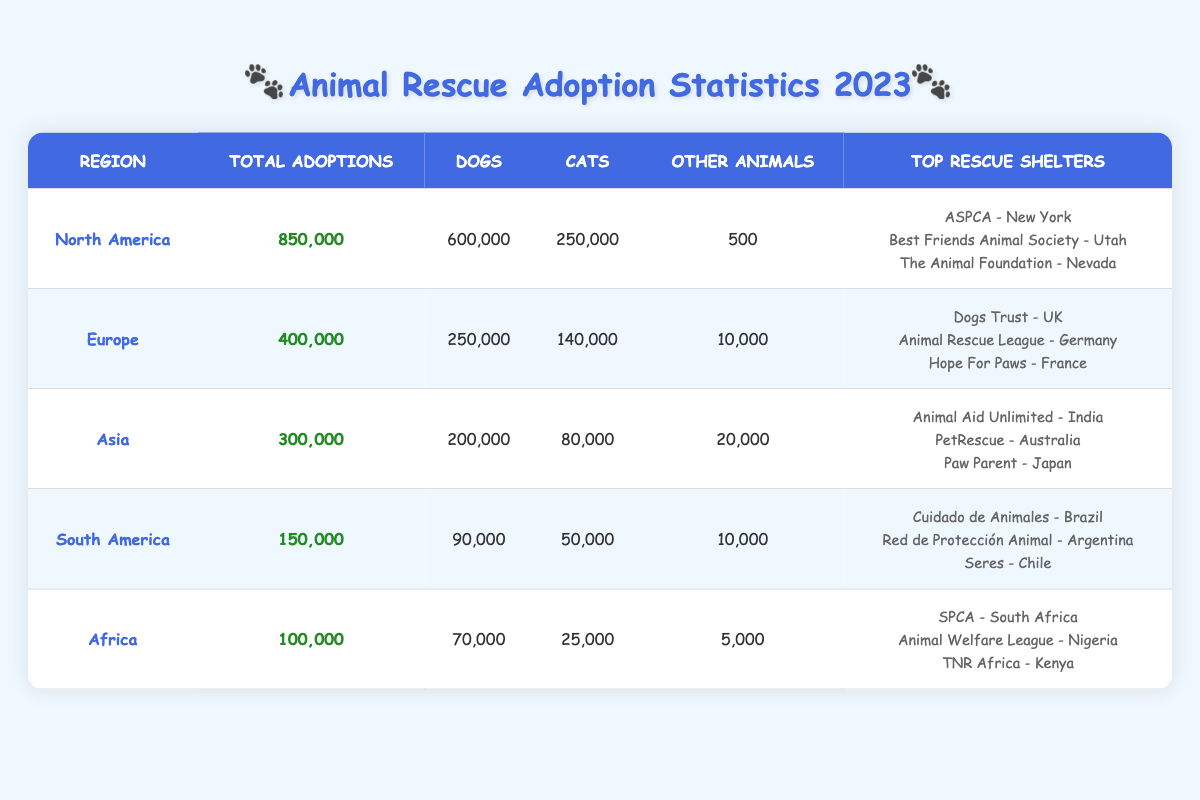What region had the highest number of total adoptions? The table indicates that North America had the highest total adoptions with 850,000. This can be directly read from the "Total Adoptions" column.
Answer: North America How many cats were adopted in Europe in 2023? The table shows that 140,000 cats were adopted in Europe, which is specifically noted in the "Cats" column for that region.
Answer: 140,000 What is the total number of dogs and cats adopted in Asia? To find the total, add the number of dogs (200,000) and cats (80,000) adopted in Asia. So, 200,000 + 80,000 equals 280,000.
Answer: 280,000 Did Africa have more total adoptions than South America? According to the table, Africa had 100,000 total adoptions while South America had 150,000. Thus, it is false that Africa had more adoptions.
Answer: No Which region had the least number of other animals adopted? The table indicates South America had 10,000 other animals adopted, which is the lowest figure when compared to Africa (5,000), Europe (10,000), and Asia (20,000), as well as North America (500). Since 5,000 from Africa is less than 10,000, Africa has the least.
Answer: Africa What is the combined number of total adoptions in North America and Europe? The total for North America is 850,000 and for Europe is 400,000. Adding them together gives 850,000 + 400,000 = 1,250,000.
Answer: 1,250,000 Which top rescue shelter is located in South America? The table lists "Cuidado de Animales - Brazil," "Red de Protección Animal - Argentina," and "Seres - Chile" as the top rescue shelters in South America. Therefore, one of the shelters listed can be considered the top shelter, and it's located in Brazil.
Answer: Cuidado de Animales - Brazil What percentage of total adoptions in Asia were dogs? To calculate the percentage of dogs adopted in Asia, divide the number of dogs (200,000) by the total adoptions (300,000) and multiply by 100. This gives (200,000 / 300,000) * 100 = 66.67%.
Answer: 66.67% Did any region adopt more than 1 million animals in total? The table indicates that the highest total adoptions were from North America (850,000), and all other regions had totals below this as well. Hence, no region adopted over 1 million animals.
Answer: No 